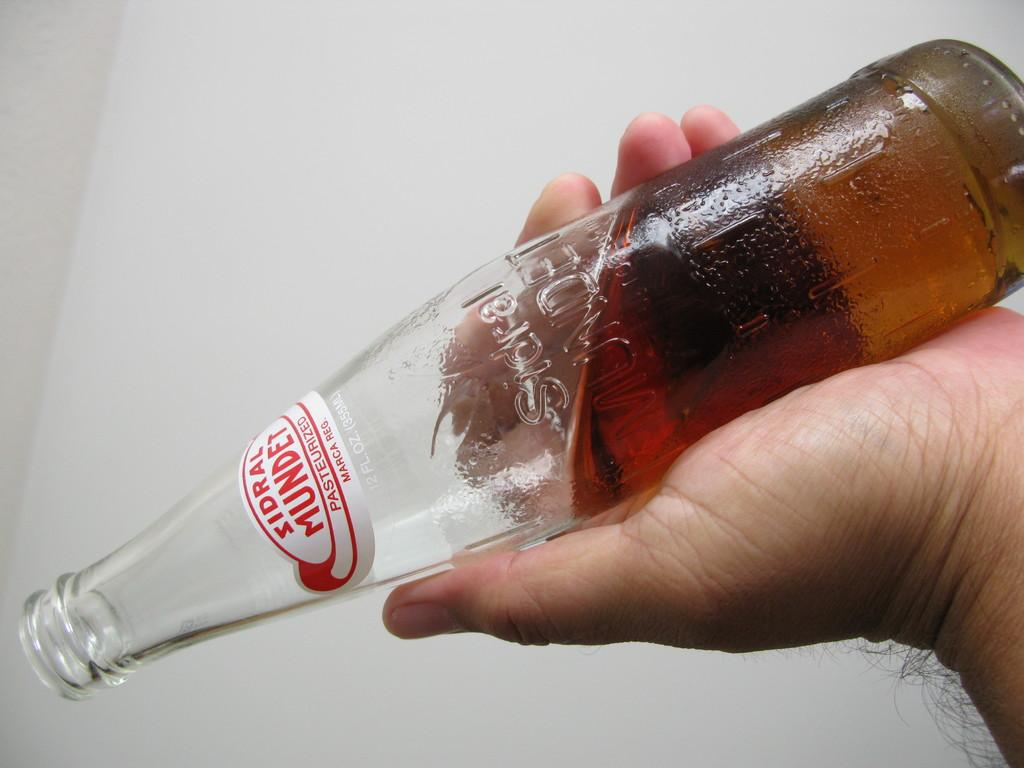Provide a one-sentence caption for the provided image. A bottle is turned upside down and is the brand Sindral Mundet. 